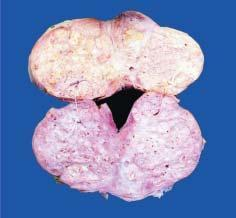what shows soft to firm, grey-white, nodularity with microcystic areas?
Answer the question using a single word or phrase. Sectioned surface of enlarged prostate 